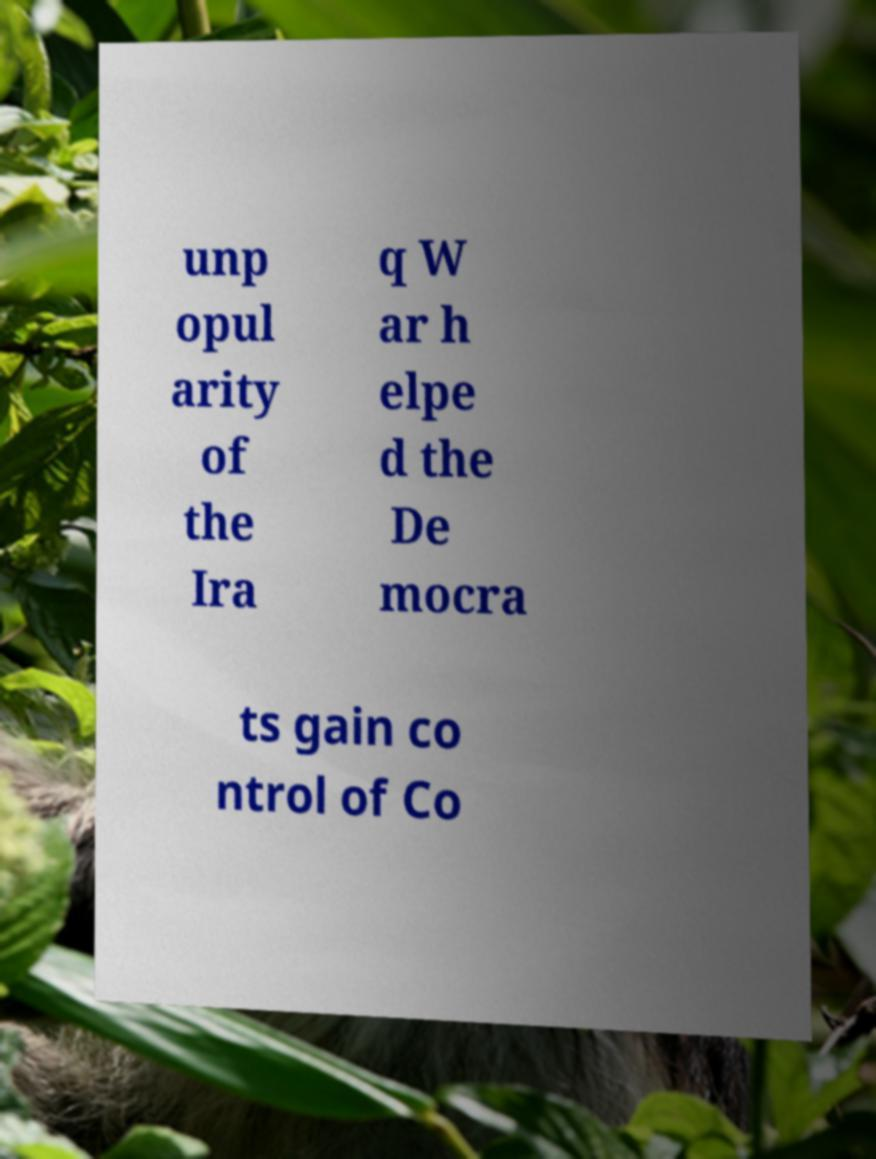Please identify and transcribe the text found in this image. unp opul arity of the Ira q W ar h elpe d the De mocra ts gain co ntrol of Co 